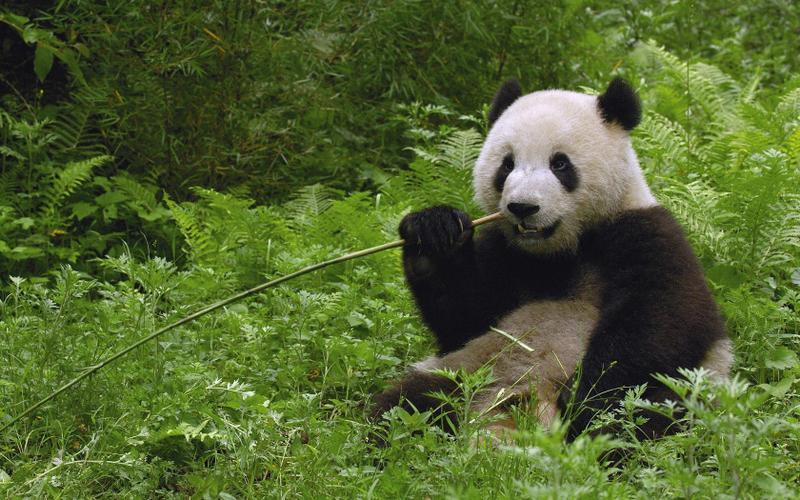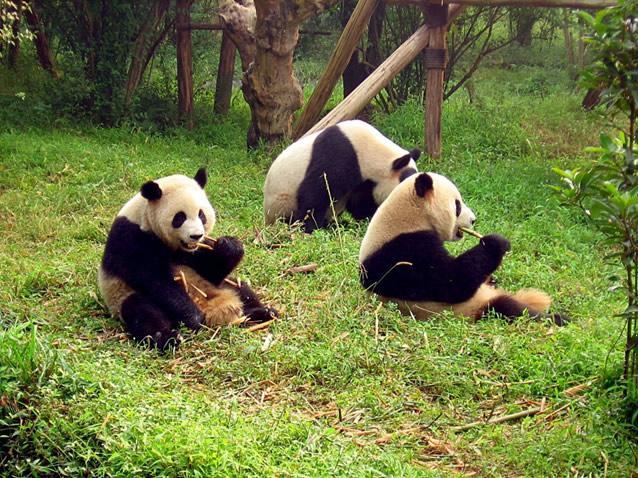The first image is the image on the left, the second image is the image on the right. Evaluate the accuracy of this statement regarding the images: "Each panda in the image, whose mouth can clearly be seen, is currently eating bamboo.". Is it true? Answer yes or no. Yes. 